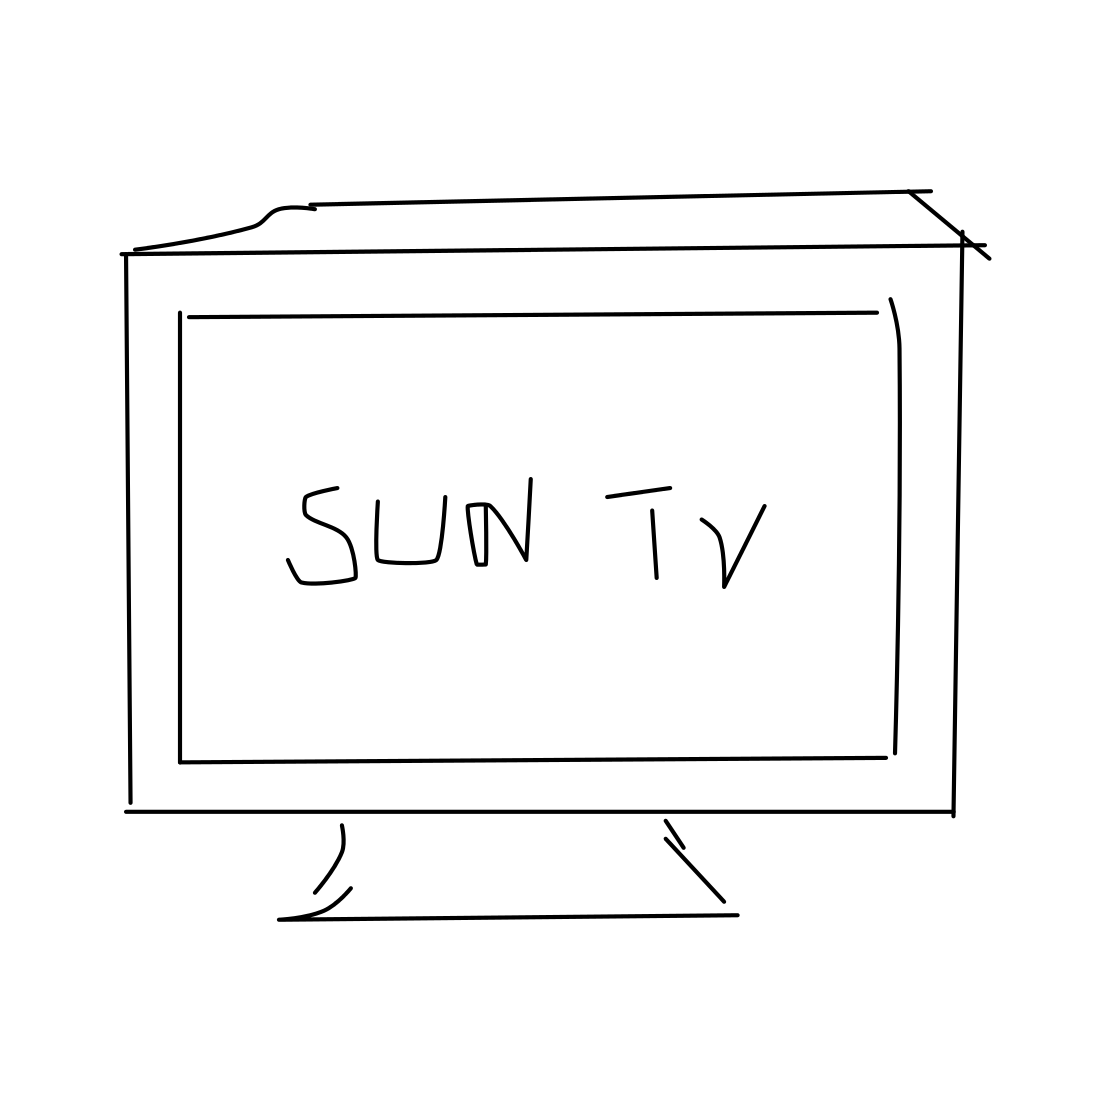Is this a tv in the image? Yes, the image depicts a simplistic representation of a television set, identifiable by its rectangular screen which displays the text 'SUN TV', and its stand at the base giving it support to stand upright. 